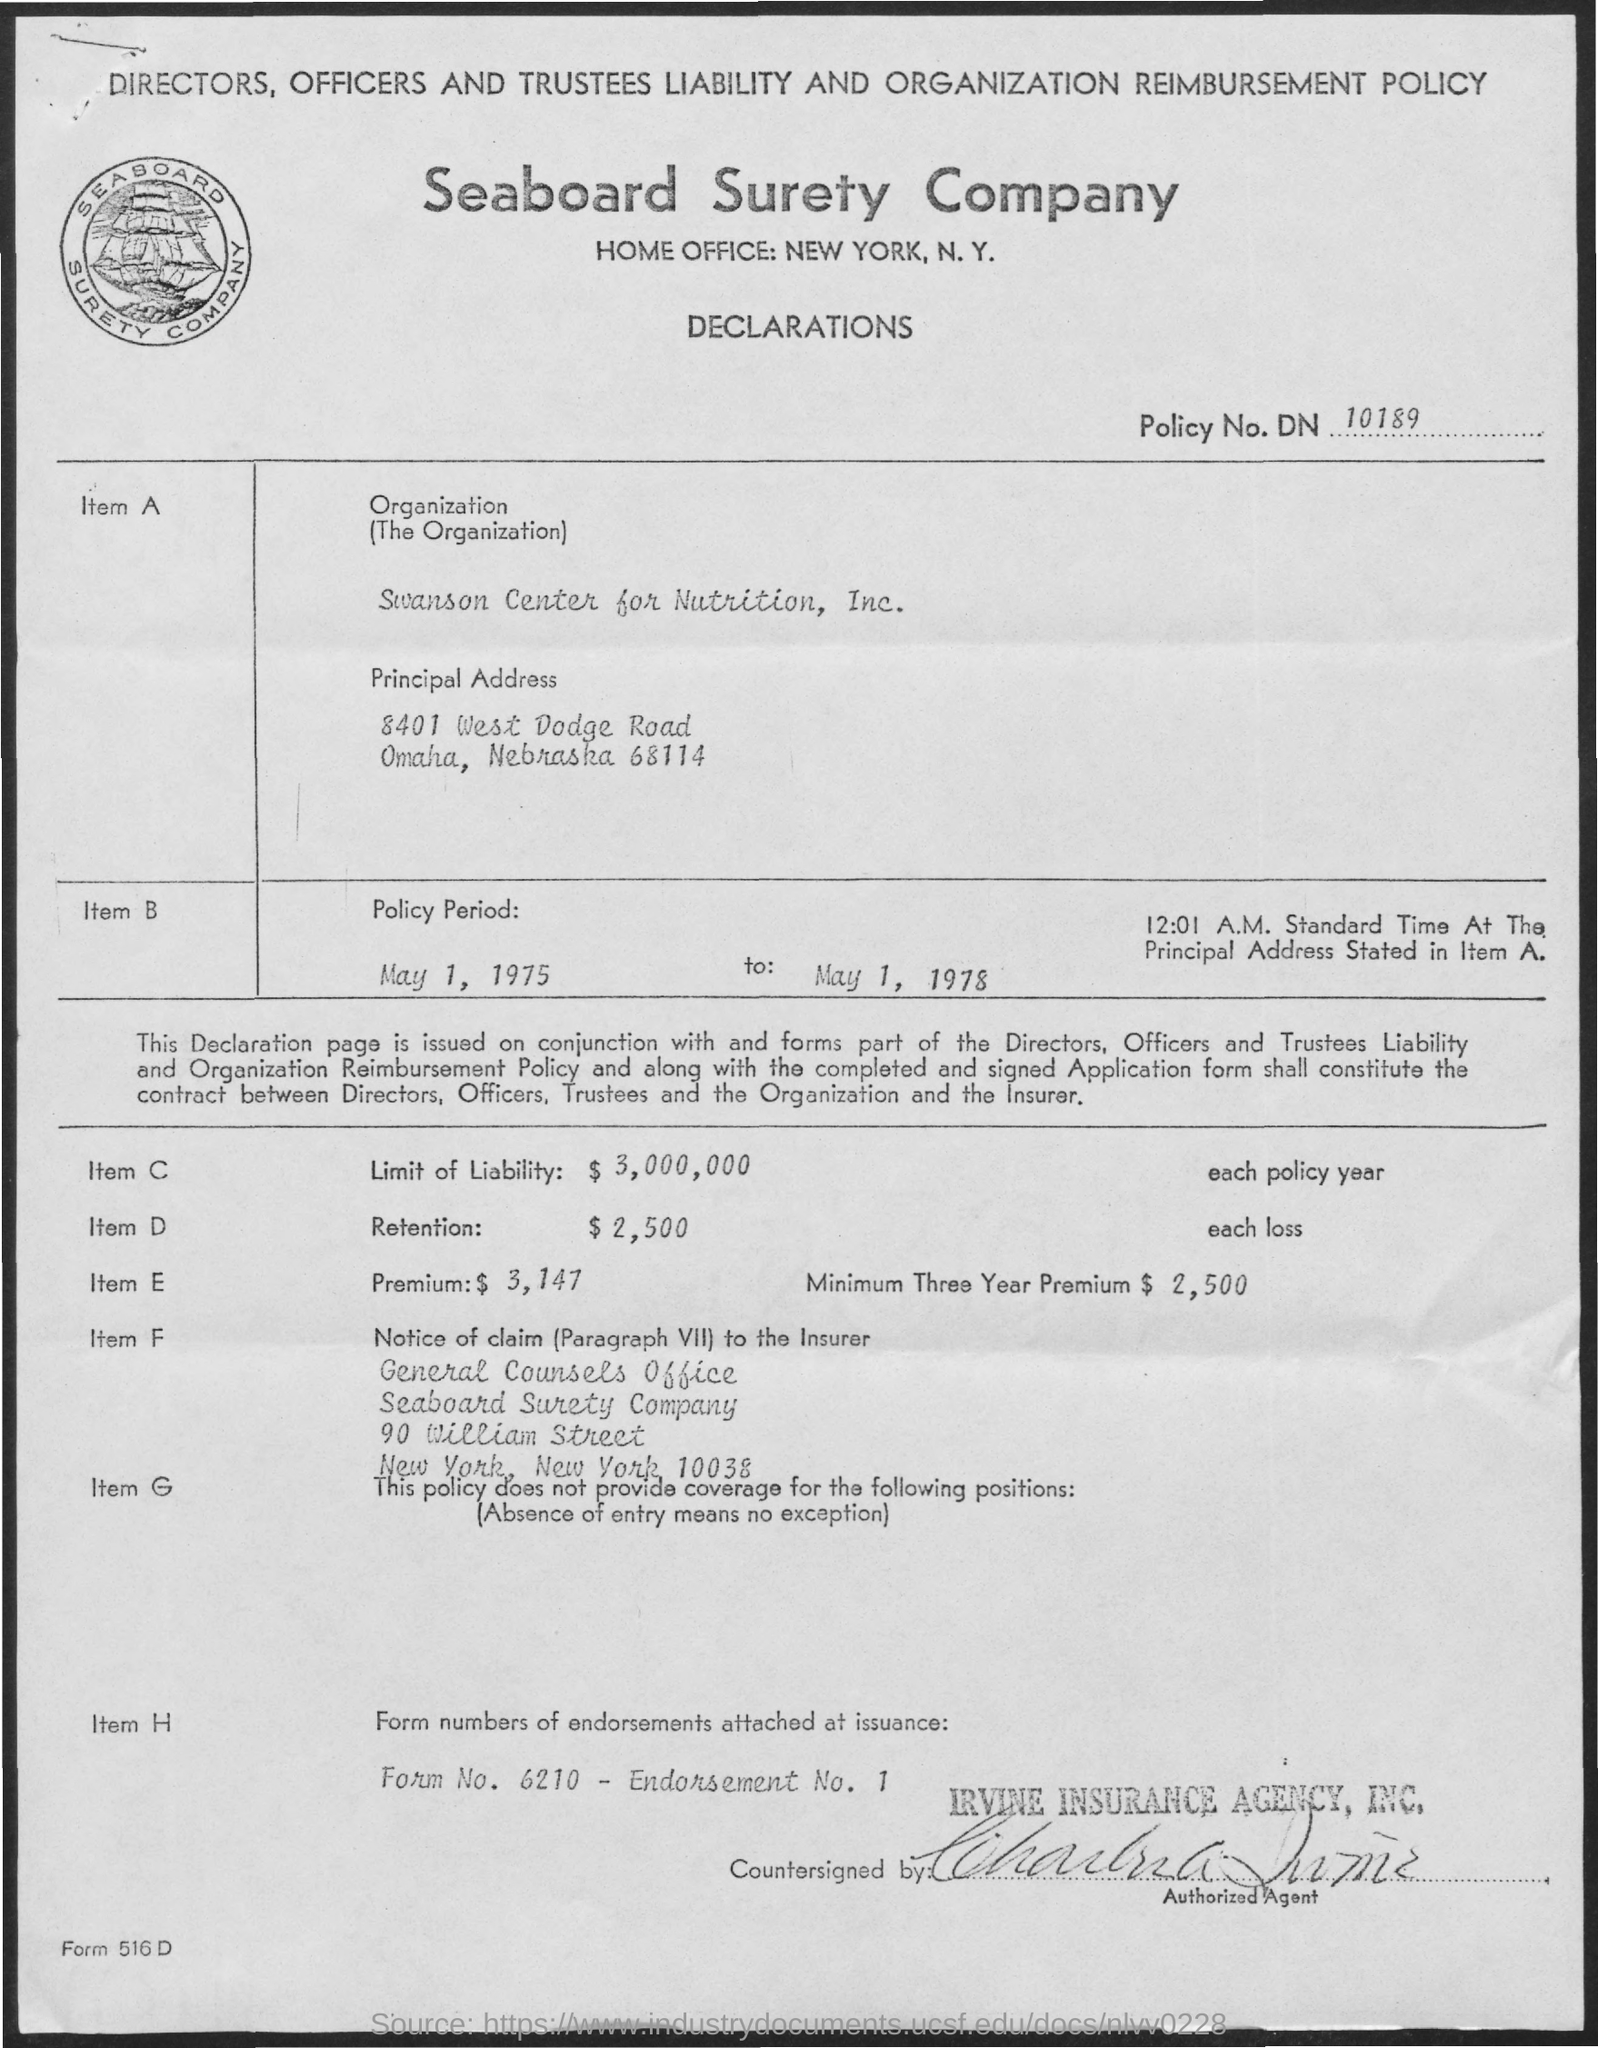What information is provided about the policy premium? The image shows that the premium for the policy is $3,147, with a specified 'Minimum Three Year Premium' amounting to $2,500.  Where should claims be reported as per this document? Claims should be reported to the 'General Counsel's Office' of Seaboard Surety Company at 90 William Street, New York, New York, 10038, as stated in the 'Notice of claim' section. 